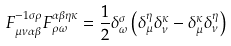Convert formula to latex. <formula><loc_0><loc_0><loc_500><loc_500>F _ { \mu \nu \alpha \beta } ^ { - 1 \sigma \rho } F _ { \rho \omega } ^ { \alpha \beta \eta \kappa } = \frac { 1 } { 2 } \delta _ { \omega } ^ { \sigma } \left ( \delta _ { \mu } ^ { \eta } \delta _ { \nu } ^ { \kappa } - \delta _ { \mu } ^ { \kappa } \delta _ { \nu } ^ { \eta } \right )</formula> 